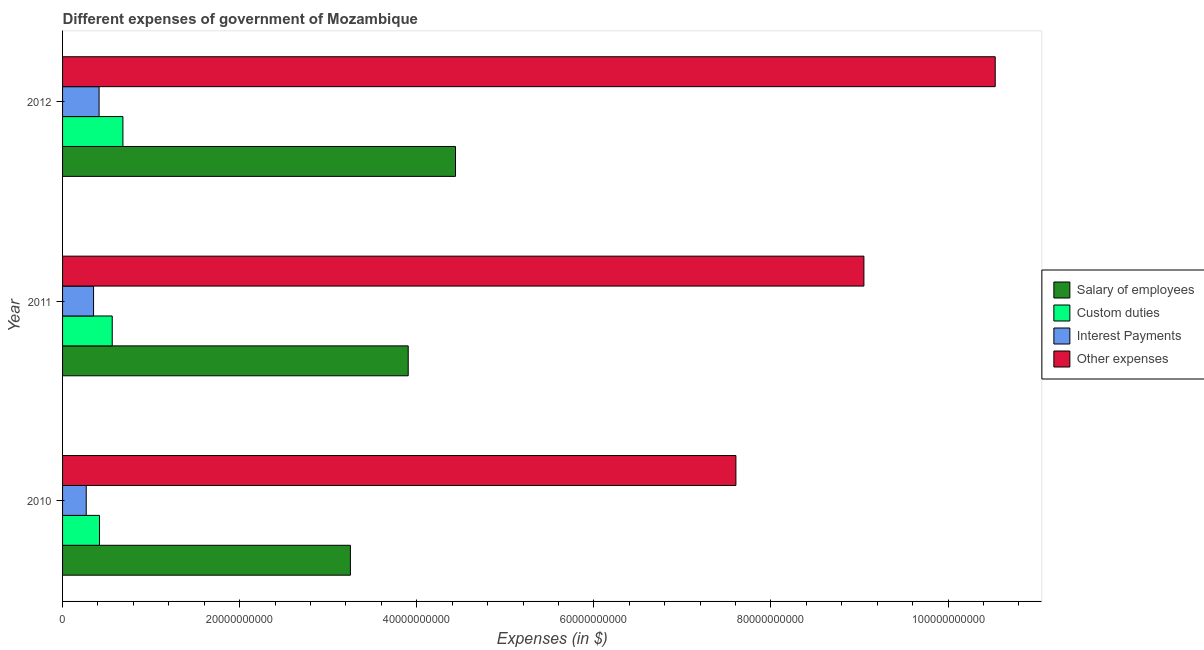How many different coloured bars are there?
Ensure brevity in your answer.  4. Are the number of bars per tick equal to the number of legend labels?
Give a very brief answer. Yes. Are the number of bars on each tick of the Y-axis equal?
Give a very brief answer. Yes. What is the label of the 2nd group of bars from the top?
Your answer should be very brief. 2011. In how many cases, is the number of bars for a given year not equal to the number of legend labels?
Ensure brevity in your answer.  0. What is the amount spent on salary of employees in 2011?
Keep it short and to the point. 3.90e+1. Across all years, what is the maximum amount spent on custom duties?
Offer a very short reply. 6.82e+09. Across all years, what is the minimum amount spent on interest payments?
Your response must be concise. 2.67e+09. What is the total amount spent on custom duties in the graph?
Your answer should be very brief. 1.66e+1. What is the difference between the amount spent on custom duties in 2010 and that in 2012?
Your answer should be very brief. -2.65e+09. What is the difference between the amount spent on custom duties in 2010 and the amount spent on salary of employees in 2012?
Provide a short and direct response. -4.02e+1. What is the average amount spent on custom duties per year?
Offer a very short reply. 5.53e+09. In the year 2010, what is the difference between the amount spent on interest payments and amount spent on other expenses?
Give a very brief answer. -7.34e+1. In how many years, is the amount spent on salary of employees greater than 92000000000 $?
Your response must be concise. 0. What is the ratio of the amount spent on custom duties in 2010 to that in 2011?
Offer a very short reply. 0.74. Is the amount spent on other expenses in 2011 less than that in 2012?
Your answer should be very brief. Yes. Is the difference between the amount spent on interest payments in 2010 and 2012 greater than the difference between the amount spent on other expenses in 2010 and 2012?
Keep it short and to the point. Yes. What is the difference between the highest and the second highest amount spent on interest payments?
Give a very brief answer. 6.24e+08. What is the difference between the highest and the lowest amount spent on custom duties?
Provide a succinct answer. 2.65e+09. Is it the case that in every year, the sum of the amount spent on interest payments and amount spent on custom duties is greater than the sum of amount spent on salary of employees and amount spent on other expenses?
Keep it short and to the point. No. What does the 1st bar from the top in 2010 represents?
Your answer should be very brief. Other expenses. What does the 4th bar from the bottom in 2011 represents?
Your answer should be compact. Other expenses. How many bars are there?
Your response must be concise. 12. How many years are there in the graph?
Your answer should be very brief. 3. Does the graph contain grids?
Ensure brevity in your answer.  No. Where does the legend appear in the graph?
Provide a succinct answer. Center right. What is the title of the graph?
Offer a very short reply. Different expenses of government of Mozambique. What is the label or title of the X-axis?
Give a very brief answer. Expenses (in $). What is the label or title of the Y-axis?
Your answer should be compact. Year. What is the Expenses (in $) in Salary of employees in 2010?
Give a very brief answer. 3.25e+1. What is the Expenses (in $) of Custom duties in 2010?
Provide a succinct answer. 4.17e+09. What is the Expenses (in $) of Interest Payments in 2010?
Ensure brevity in your answer.  2.67e+09. What is the Expenses (in $) in Other expenses in 2010?
Provide a succinct answer. 7.60e+1. What is the Expenses (in $) in Salary of employees in 2011?
Give a very brief answer. 3.90e+1. What is the Expenses (in $) in Custom duties in 2011?
Keep it short and to the point. 5.61e+09. What is the Expenses (in $) in Interest Payments in 2011?
Your answer should be compact. 3.50e+09. What is the Expenses (in $) of Other expenses in 2011?
Ensure brevity in your answer.  9.05e+1. What is the Expenses (in $) in Salary of employees in 2012?
Offer a very short reply. 4.44e+1. What is the Expenses (in $) of Custom duties in 2012?
Give a very brief answer. 6.82e+09. What is the Expenses (in $) of Interest Payments in 2012?
Keep it short and to the point. 4.13e+09. What is the Expenses (in $) in Other expenses in 2012?
Your answer should be compact. 1.05e+11. Across all years, what is the maximum Expenses (in $) of Salary of employees?
Offer a terse response. 4.44e+1. Across all years, what is the maximum Expenses (in $) in Custom duties?
Your answer should be compact. 6.82e+09. Across all years, what is the maximum Expenses (in $) in Interest Payments?
Provide a short and direct response. 4.13e+09. Across all years, what is the maximum Expenses (in $) of Other expenses?
Provide a succinct answer. 1.05e+11. Across all years, what is the minimum Expenses (in $) of Salary of employees?
Make the answer very short. 3.25e+1. Across all years, what is the minimum Expenses (in $) in Custom duties?
Your response must be concise. 4.17e+09. Across all years, what is the minimum Expenses (in $) in Interest Payments?
Offer a very short reply. 2.67e+09. Across all years, what is the minimum Expenses (in $) of Other expenses?
Keep it short and to the point. 7.60e+1. What is the total Expenses (in $) of Salary of employees in the graph?
Your response must be concise. 1.16e+11. What is the total Expenses (in $) in Custom duties in the graph?
Your answer should be compact. 1.66e+1. What is the total Expenses (in $) of Interest Payments in the graph?
Offer a terse response. 1.03e+1. What is the total Expenses (in $) in Other expenses in the graph?
Your answer should be compact. 2.72e+11. What is the difference between the Expenses (in $) of Salary of employees in 2010 and that in 2011?
Your response must be concise. -6.53e+09. What is the difference between the Expenses (in $) of Custom duties in 2010 and that in 2011?
Ensure brevity in your answer.  -1.44e+09. What is the difference between the Expenses (in $) in Interest Payments in 2010 and that in 2011?
Provide a succinct answer. -8.28e+08. What is the difference between the Expenses (in $) in Other expenses in 2010 and that in 2011?
Your response must be concise. -1.45e+1. What is the difference between the Expenses (in $) of Salary of employees in 2010 and that in 2012?
Your answer should be compact. -1.19e+1. What is the difference between the Expenses (in $) in Custom duties in 2010 and that in 2012?
Provide a succinct answer. -2.65e+09. What is the difference between the Expenses (in $) of Interest Payments in 2010 and that in 2012?
Give a very brief answer. -1.45e+09. What is the difference between the Expenses (in $) of Other expenses in 2010 and that in 2012?
Provide a short and direct response. -2.93e+1. What is the difference between the Expenses (in $) in Salary of employees in 2011 and that in 2012?
Give a very brief answer. -5.34e+09. What is the difference between the Expenses (in $) in Custom duties in 2011 and that in 2012?
Provide a succinct answer. -1.21e+09. What is the difference between the Expenses (in $) in Interest Payments in 2011 and that in 2012?
Your response must be concise. -6.24e+08. What is the difference between the Expenses (in $) of Other expenses in 2011 and that in 2012?
Your response must be concise. -1.48e+1. What is the difference between the Expenses (in $) in Salary of employees in 2010 and the Expenses (in $) in Custom duties in 2011?
Your answer should be compact. 2.69e+1. What is the difference between the Expenses (in $) of Salary of employees in 2010 and the Expenses (in $) of Interest Payments in 2011?
Your response must be concise. 2.90e+1. What is the difference between the Expenses (in $) of Salary of employees in 2010 and the Expenses (in $) of Other expenses in 2011?
Offer a very short reply. -5.80e+1. What is the difference between the Expenses (in $) of Custom duties in 2010 and the Expenses (in $) of Interest Payments in 2011?
Your answer should be very brief. 6.68e+08. What is the difference between the Expenses (in $) in Custom duties in 2010 and the Expenses (in $) in Other expenses in 2011?
Ensure brevity in your answer.  -8.63e+1. What is the difference between the Expenses (in $) of Interest Payments in 2010 and the Expenses (in $) of Other expenses in 2011?
Offer a terse response. -8.78e+1. What is the difference between the Expenses (in $) of Salary of employees in 2010 and the Expenses (in $) of Custom duties in 2012?
Ensure brevity in your answer.  2.57e+1. What is the difference between the Expenses (in $) of Salary of employees in 2010 and the Expenses (in $) of Interest Payments in 2012?
Your response must be concise. 2.84e+1. What is the difference between the Expenses (in $) in Salary of employees in 2010 and the Expenses (in $) in Other expenses in 2012?
Offer a terse response. -7.28e+1. What is the difference between the Expenses (in $) in Custom duties in 2010 and the Expenses (in $) in Interest Payments in 2012?
Provide a short and direct response. 4.41e+07. What is the difference between the Expenses (in $) in Custom duties in 2010 and the Expenses (in $) in Other expenses in 2012?
Make the answer very short. -1.01e+11. What is the difference between the Expenses (in $) of Interest Payments in 2010 and the Expenses (in $) of Other expenses in 2012?
Offer a very short reply. -1.03e+11. What is the difference between the Expenses (in $) of Salary of employees in 2011 and the Expenses (in $) of Custom duties in 2012?
Ensure brevity in your answer.  3.22e+1. What is the difference between the Expenses (in $) of Salary of employees in 2011 and the Expenses (in $) of Interest Payments in 2012?
Your response must be concise. 3.49e+1. What is the difference between the Expenses (in $) in Salary of employees in 2011 and the Expenses (in $) in Other expenses in 2012?
Provide a short and direct response. -6.63e+1. What is the difference between the Expenses (in $) of Custom duties in 2011 and the Expenses (in $) of Interest Payments in 2012?
Give a very brief answer. 1.48e+09. What is the difference between the Expenses (in $) of Custom duties in 2011 and the Expenses (in $) of Other expenses in 2012?
Provide a short and direct response. -9.97e+1. What is the difference between the Expenses (in $) of Interest Payments in 2011 and the Expenses (in $) of Other expenses in 2012?
Your response must be concise. -1.02e+11. What is the average Expenses (in $) in Salary of employees per year?
Give a very brief answer. 3.86e+1. What is the average Expenses (in $) in Custom duties per year?
Keep it short and to the point. 5.53e+09. What is the average Expenses (in $) in Interest Payments per year?
Your response must be concise. 3.43e+09. What is the average Expenses (in $) of Other expenses per year?
Offer a terse response. 9.06e+1. In the year 2010, what is the difference between the Expenses (in $) in Salary of employees and Expenses (in $) in Custom duties?
Make the answer very short. 2.83e+1. In the year 2010, what is the difference between the Expenses (in $) of Salary of employees and Expenses (in $) of Interest Payments?
Give a very brief answer. 2.98e+1. In the year 2010, what is the difference between the Expenses (in $) in Salary of employees and Expenses (in $) in Other expenses?
Make the answer very short. -4.35e+1. In the year 2010, what is the difference between the Expenses (in $) of Custom duties and Expenses (in $) of Interest Payments?
Your response must be concise. 1.50e+09. In the year 2010, what is the difference between the Expenses (in $) of Custom duties and Expenses (in $) of Other expenses?
Give a very brief answer. -7.19e+1. In the year 2010, what is the difference between the Expenses (in $) in Interest Payments and Expenses (in $) in Other expenses?
Your answer should be compact. -7.34e+1. In the year 2011, what is the difference between the Expenses (in $) in Salary of employees and Expenses (in $) in Custom duties?
Offer a very short reply. 3.34e+1. In the year 2011, what is the difference between the Expenses (in $) of Salary of employees and Expenses (in $) of Interest Payments?
Offer a very short reply. 3.55e+1. In the year 2011, what is the difference between the Expenses (in $) of Salary of employees and Expenses (in $) of Other expenses?
Provide a succinct answer. -5.15e+1. In the year 2011, what is the difference between the Expenses (in $) in Custom duties and Expenses (in $) in Interest Payments?
Keep it short and to the point. 2.11e+09. In the year 2011, what is the difference between the Expenses (in $) in Custom duties and Expenses (in $) in Other expenses?
Keep it short and to the point. -8.49e+1. In the year 2011, what is the difference between the Expenses (in $) in Interest Payments and Expenses (in $) in Other expenses?
Provide a succinct answer. -8.70e+1. In the year 2012, what is the difference between the Expenses (in $) of Salary of employees and Expenses (in $) of Custom duties?
Make the answer very short. 3.76e+1. In the year 2012, what is the difference between the Expenses (in $) in Salary of employees and Expenses (in $) in Interest Payments?
Make the answer very short. 4.02e+1. In the year 2012, what is the difference between the Expenses (in $) in Salary of employees and Expenses (in $) in Other expenses?
Your answer should be very brief. -6.09e+1. In the year 2012, what is the difference between the Expenses (in $) in Custom duties and Expenses (in $) in Interest Payments?
Ensure brevity in your answer.  2.69e+09. In the year 2012, what is the difference between the Expenses (in $) of Custom duties and Expenses (in $) of Other expenses?
Make the answer very short. -9.85e+1. In the year 2012, what is the difference between the Expenses (in $) in Interest Payments and Expenses (in $) in Other expenses?
Provide a succinct answer. -1.01e+11. What is the ratio of the Expenses (in $) of Salary of employees in 2010 to that in 2011?
Provide a succinct answer. 0.83. What is the ratio of the Expenses (in $) in Custom duties in 2010 to that in 2011?
Your answer should be very brief. 0.74. What is the ratio of the Expenses (in $) of Interest Payments in 2010 to that in 2011?
Give a very brief answer. 0.76. What is the ratio of the Expenses (in $) of Other expenses in 2010 to that in 2011?
Your answer should be very brief. 0.84. What is the ratio of the Expenses (in $) of Salary of employees in 2010 to that in 2012?
Give a very brief answer. 0.73. What is the ratio of the Expenses (in $) in Custom duties in 2010 to that in 2012?
Your response must be concise. 0.61. What is the ratio of the Expenses (in $) of Interest Payments in 2010 to that in 2012?
Provide a succinct answer. 0.65. What is the ratio of the Expenses (in $) of Other expenses in 2010 to that in 2012?
Offer a very short reply. 0.72. What is the ratio of the Expenses (in $) of Salary of employees in 2011 to that in 2012?
Your response must be concise. 0.88. What is the ratio of the Expenses (in $) of Custom duties in 2011 to that in 2012?
Offer a terse response. 0.82. What is the ratio of the Expenses (in $) of Interest Payments in 2011 to that in 2012?
Make the answer very short. 0.85. What is the ratio of the Expenses (in $) in Other expenses in 2011 to that in 2012?
Your answer should be compact. 0.86. What is the difference between the highest and the second highest Expenses (in $) of Salary of employees?
Ensure brevity in your answer.  5.34e+09. What is the difference between the highest and the second highest Expenses (in $) of Custom duties?
Offer a terse response. 1.21e+09. What is the difference between the highest and the second highest Expenses (in $) in Interest Payments?
Your answer should be compact. 6.24e+08. What is the difference between the highest and the second highest Expenses (in $) in Other expenses?
Provide a succinct answer. 1.48e+1. What is the difference between the highest and the lowest Expenses (in $) of Salary of employees?
Offer a very short reply. 1.19e+1. What is the difference between the highest and the lowest Expenses (in $) in Custom duties?
Provide a succinct answer. 2.65e+09. What is the difference between the highest and the lowest Expenses (in $) of Interest Payments?
Make the answer very short. 1.45e+09. What is the difference between the highest and the lowest Expenses (in $) of Other expenses?
Your response must be concise. 2.93e+1. 